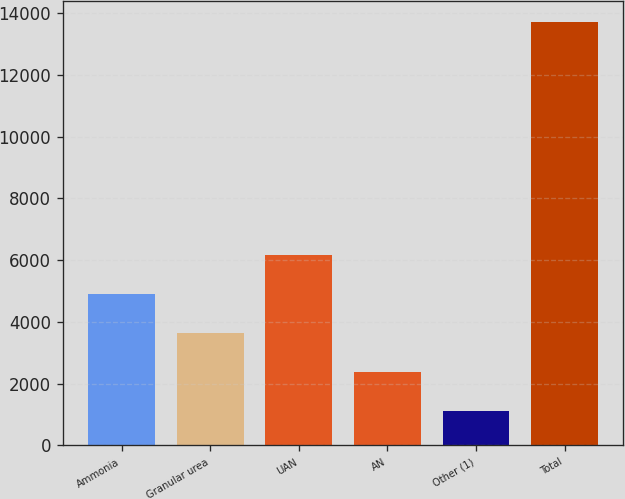Convert chart to OTSL. <chart><loc_0><loc_0><loc_500><loc_500><bar_chart><fcel>Ammonia<fcel>Granular urea<fcel>UAN<fcel>AN<fcel>Other (1)<fcel>Total<nl><fcel>4891<fcel>3630<fcel>6152<fcel>2369<fcel>1108<fcel>13718<nl></chart> 